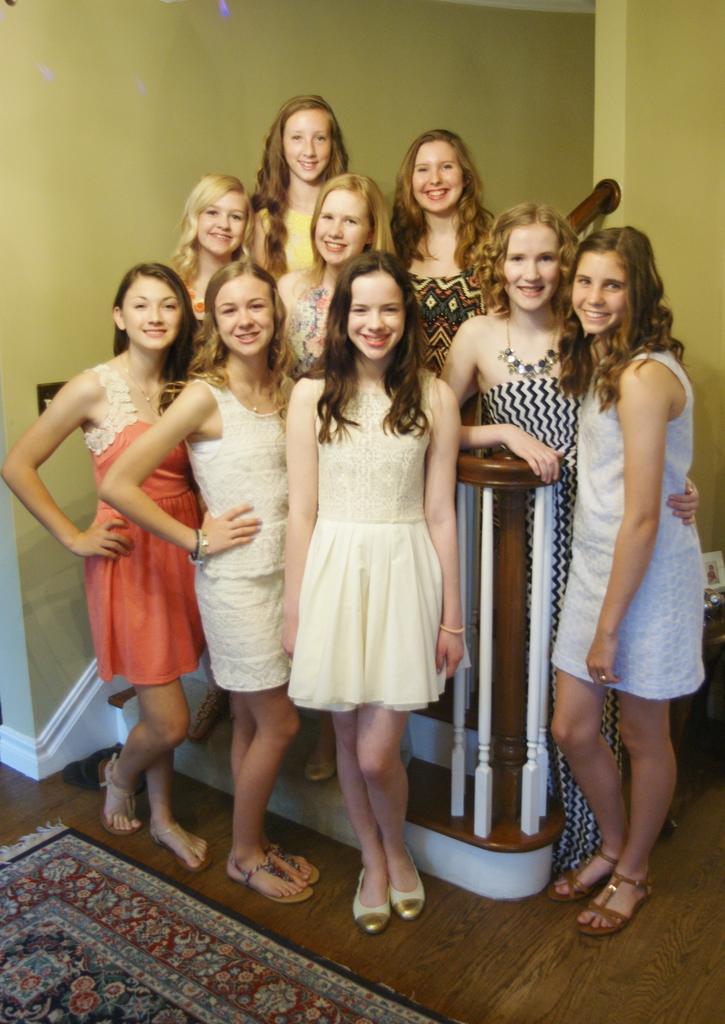Can you describe this image briefly? In this image there are a group of women standing, there is a wooden floor towards the bottom of the image, there is a mat towards the bottom of the image, at the background of the image there is a wall. 